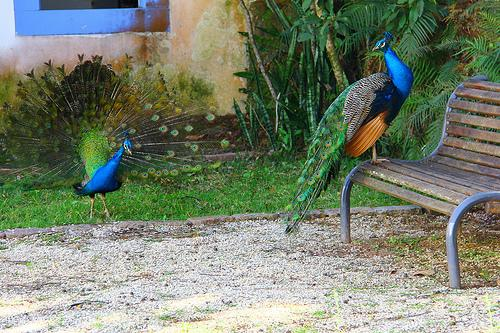What is the condition of the outdoor wall and what is the reason behind its appearance? The outdoor wall is dirty, stained, and mossy, likely due to algae stains and damage on the building's side. What type of scenery or location does the image depict and what are some interactions involving peacocks? The image depicts an outdoor scene near a building with grass, gravel, and tropical plants. Peacocks are interacting with the environment, such as standing on a bench, looking behind themselves, and displaying their bright orange feathers. What is the main type of surface where the peacocks are standing? The peacocks are mainly standing on a light color gravel surface and grassy area. Describe the type of bench and its characteristics seen in the image. The bench in the image has metal legs and wooden slats, and one of its metal legs is the closest to the viewer. What type of area does the image with "grass next to gravel area" represent? The image represents a patch of grass adjacent to a gravel surface. Provide a description of the peacock's appearance while standing on a bench. The peacock standing on the bench has its tail open, displaying bright orange feathers on its wing. Identify the type of bird that appears multiple times in the image and describe its state in the first mentioned image. A male peacock appears multiple times in the image, and in the first image, it has its tail feathers extended. Count the number of peacocks mentioned in the image, including those with specific actions or descriptions. There are 19 peacocks mentioned in the image, including those with specific actions or descriptions. What are the plants found behind the peacocks and how can they be described? The plants behind the peacocks are tropical and green, most likely found outdoors. What type of architectural feature of the building is mentioned and what color is it? A blue outdoor window frame, which is wood trimmed, appears on the building. 